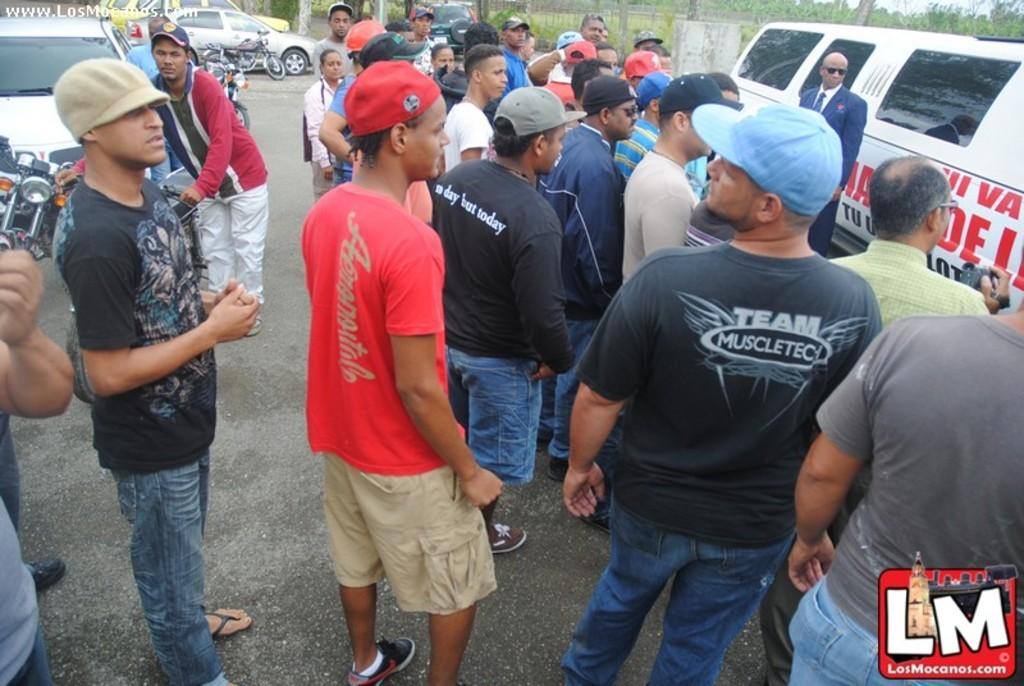What is the main subject of the image? The main subject of the image is a group of people. How can you describe the appearance of the people in the image? The people are wearing different color dresses. What can be seen in the background of the image? There are vehicles and trees visible in the background, as well as fencing. What type of orange is being used as a prop in the image? There is no orange present in the image. 